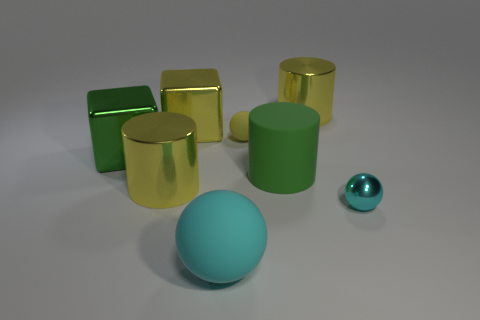What number of cubes are on the left side of the cyan ball that is to the left of the tiny object that is behind the large green metal object?
Give a very brief answer. 2. What number of brown objects are either spheres or large metallic cylinders?
Offer a very short reply. 0. Does the yellow matte ball have the same size as the metal cube to the right of the green block?
Provide a succinct answer. No. There is another small thing that is the same shape as the yellow matte object; what is its material?
Offer a terse response. Metal. What number of other things are there of the same size as the yellow ball?
Provide a short and direct response. 1. There is a thing on the right side of the large yellow cylinder on the right side of the yellow metal cylinder that is left of the yellow metallic block; what is its shape?
Ensure brevity in your answer.  Sphere. There is a rubber object that is behind the cyan shiny thing and to the left of the matte cylinder; what is its shape?
Provide a short and direct response. Sphere. How many things are either large green metal blocks or matte things that are in front of the big green block?
Your answer should be compact. 3. Do the large green cylinder and the large green block have the same material?
Give a very brief answer. No. What number of other objects are the same shape as the tiny shiny object?
Your response must be concise. 2. 